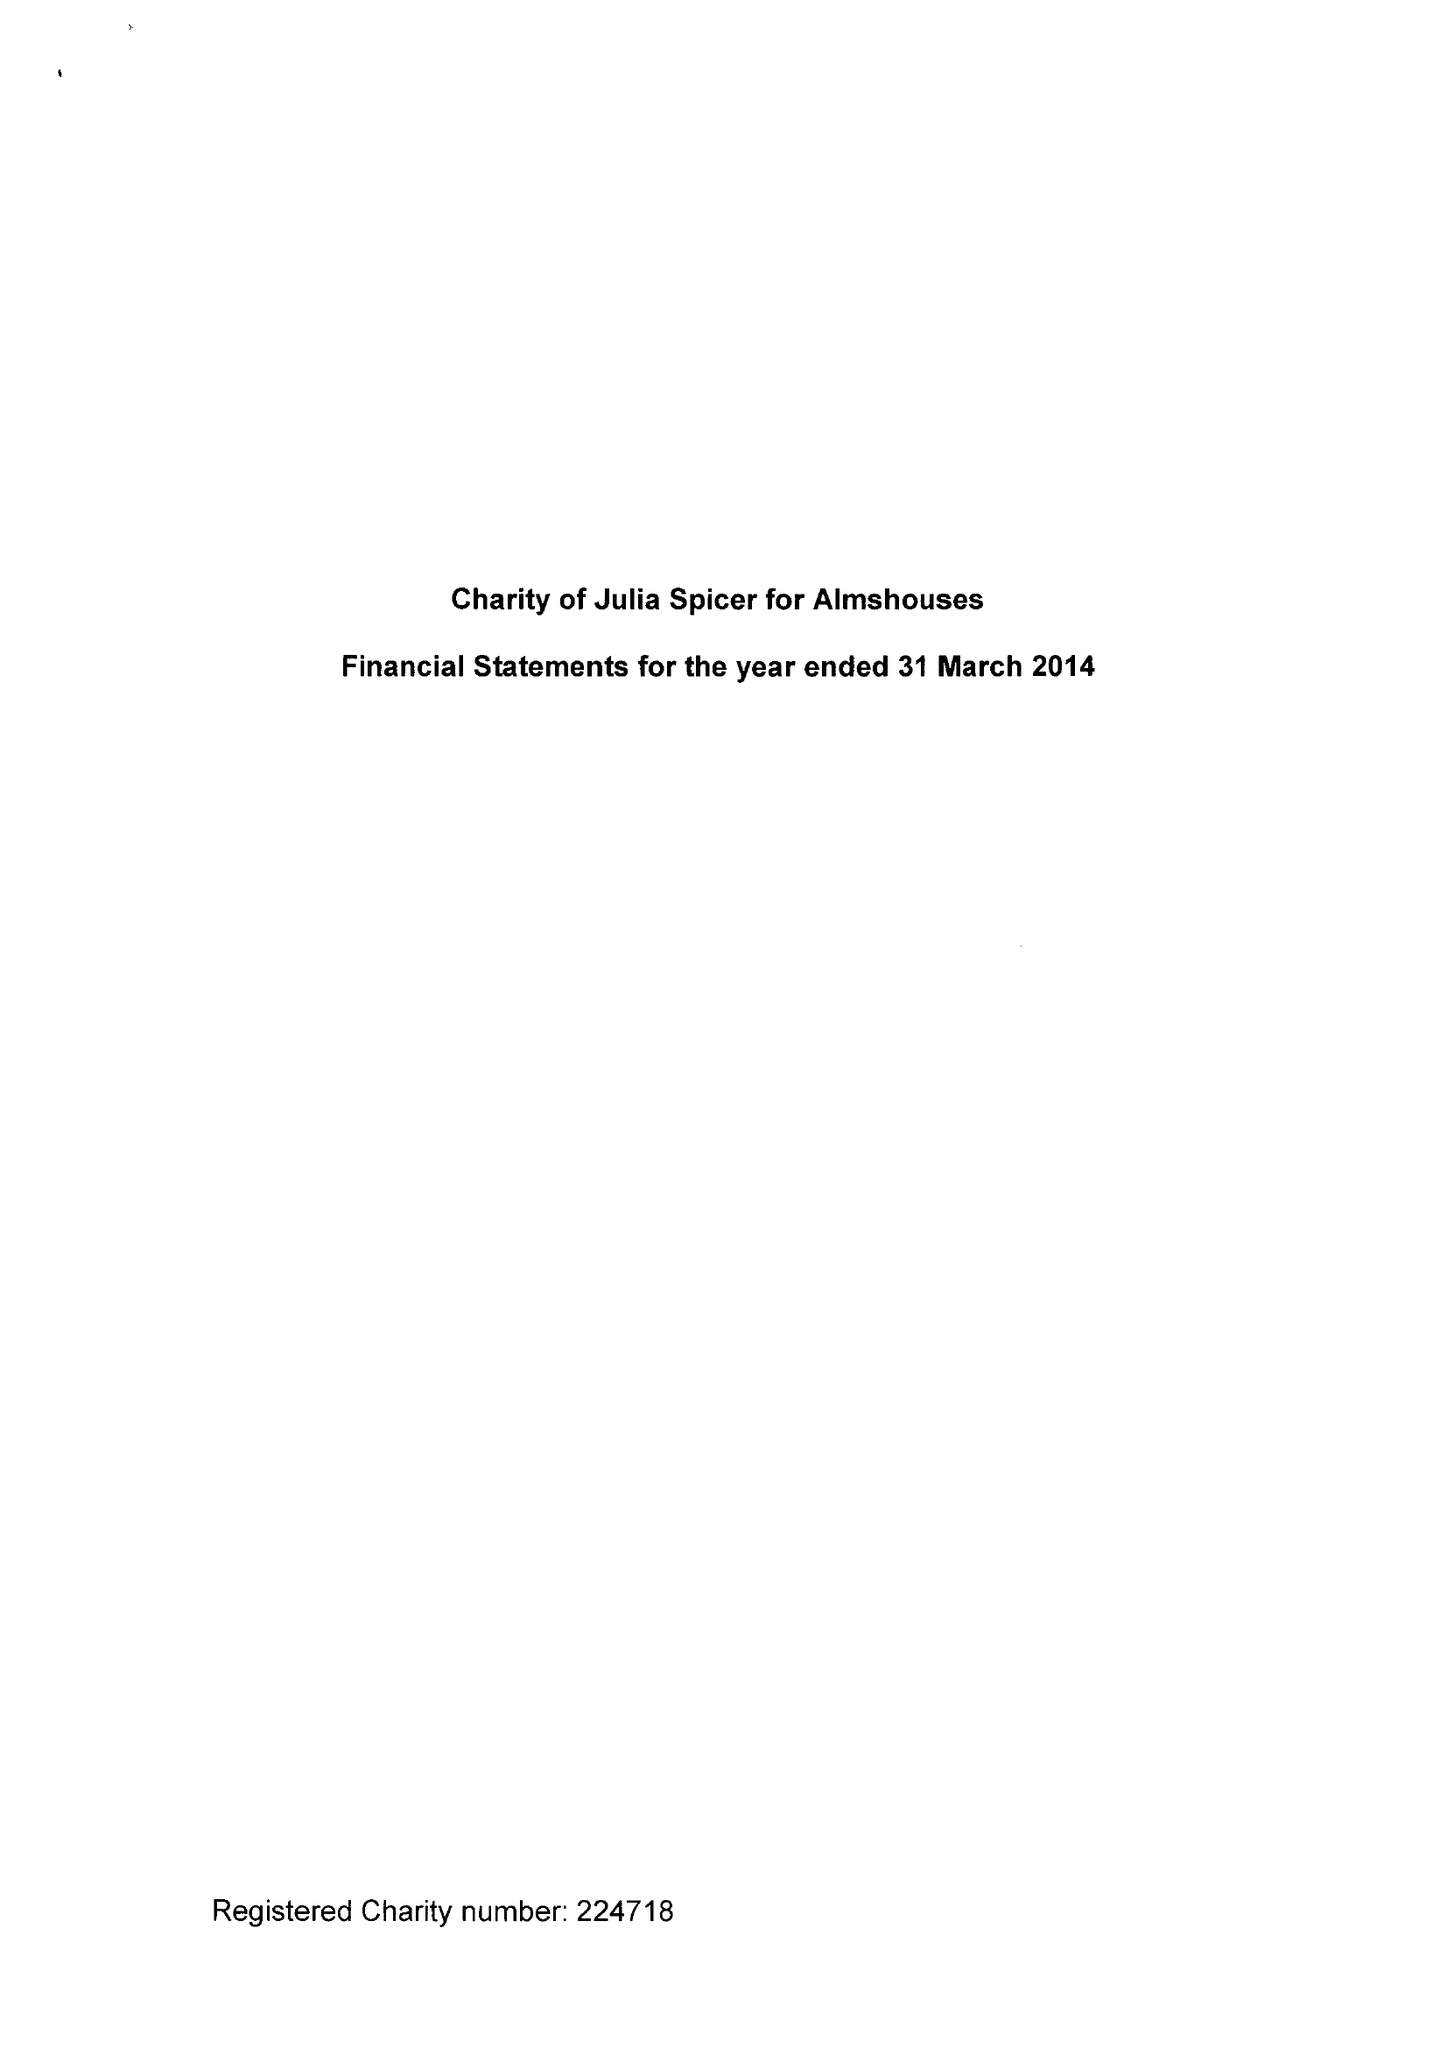What is the value for the address__postcode?
Answer the question using a single word or phrase. CR0 9XP 